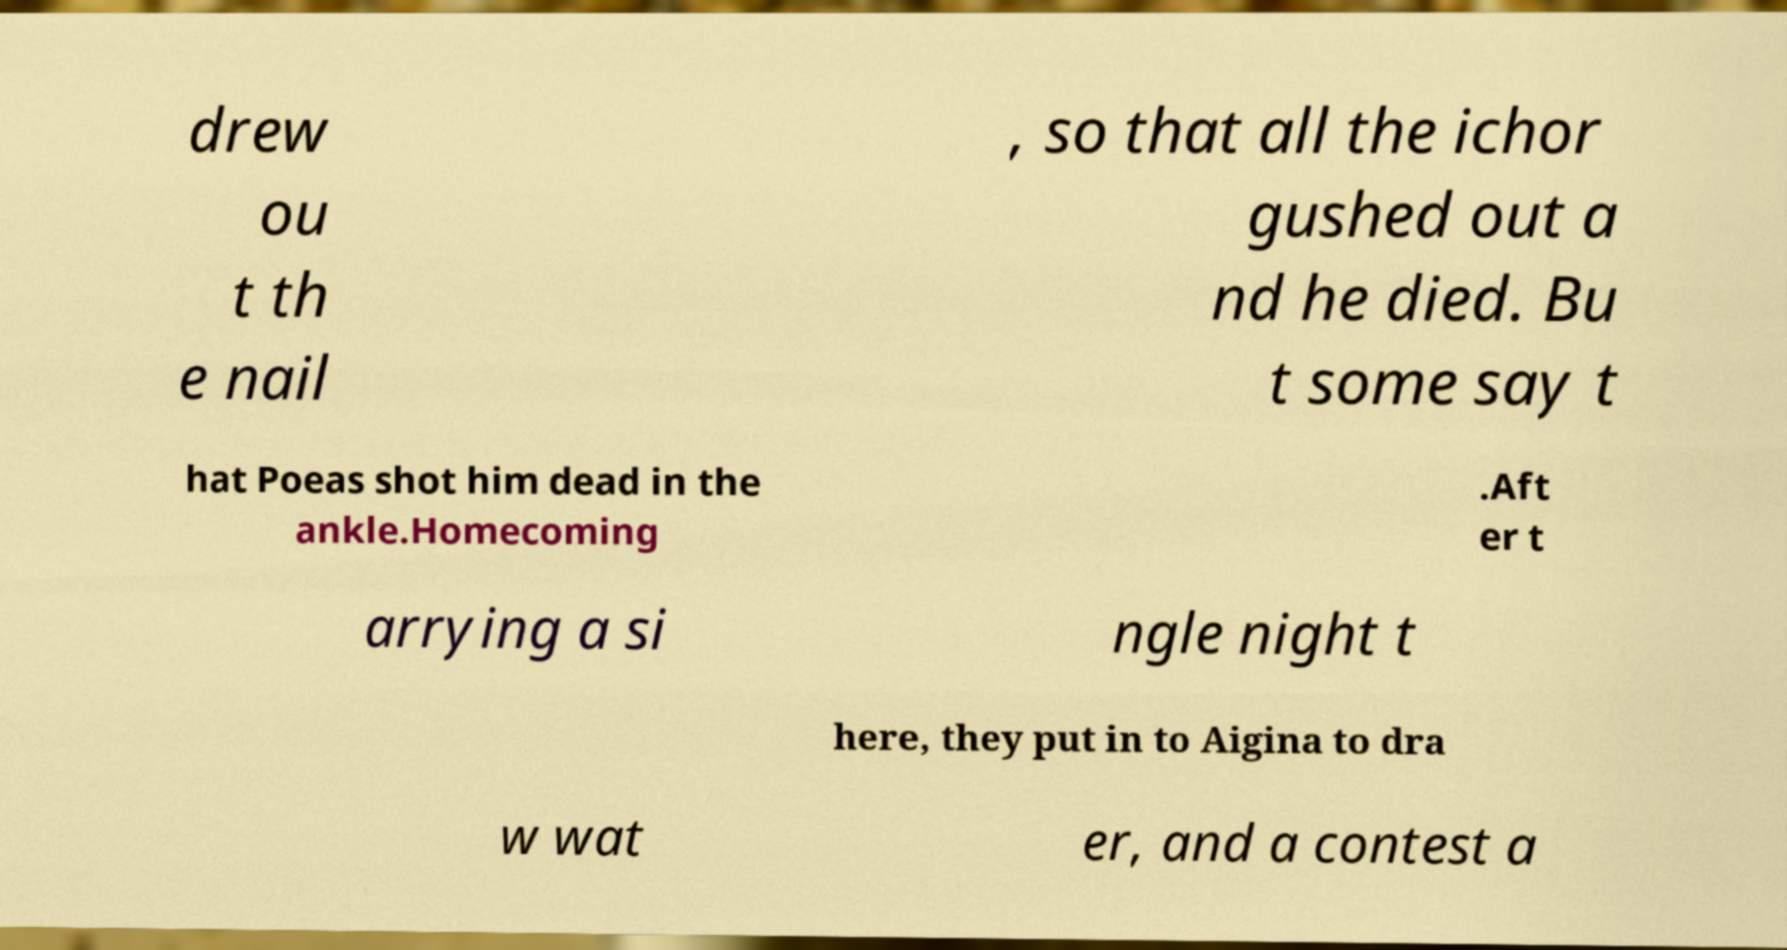For documentation purposes, I need the text within this image transcribed. Could you provide that? drew ou t th e nail , so that all the ichor gushed out a nd he died. Bu t some say t hat Poeas shot him dead in the ankle.Homecoming .Aft er t arrying a si ngle night t here, they put in to Aigina to dra w wat er, and a contest a 